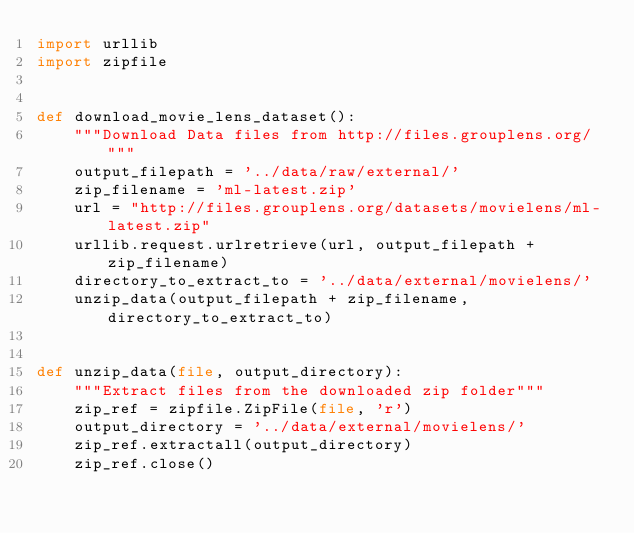Convert code to text. <code><loc_0><loc_0><loc_500><loc_500><_Python_>import urllib
import zipfile


def download_movie_lens_dataset():
    """Download Data files from http://files.grouplens.org/ """
    output_filepath = '../data/raw/external/'
    zip_filename = 'ml-latest.zip'
    url = "http://files.grouplens.org/datasets/movielens/ml-latest.zip"
    urllib.request.urlretrieve(url, output_filepath + zip_filename)
    directory_to_extract_to = '../data/external/movielens/'
    unzip_data(output_filepath + zip_filename, directory_to_extract_to)


def unzip_data(file, output_directory):
    """Extract files from the downloaded zip folder"""
    zip_ref = zipfile.ZipFile(file, 'r')
    output_directory = '../data/external/movielens/'
    zip_ref.extractall(output_directory)
    zip_ref.close()
</code> 